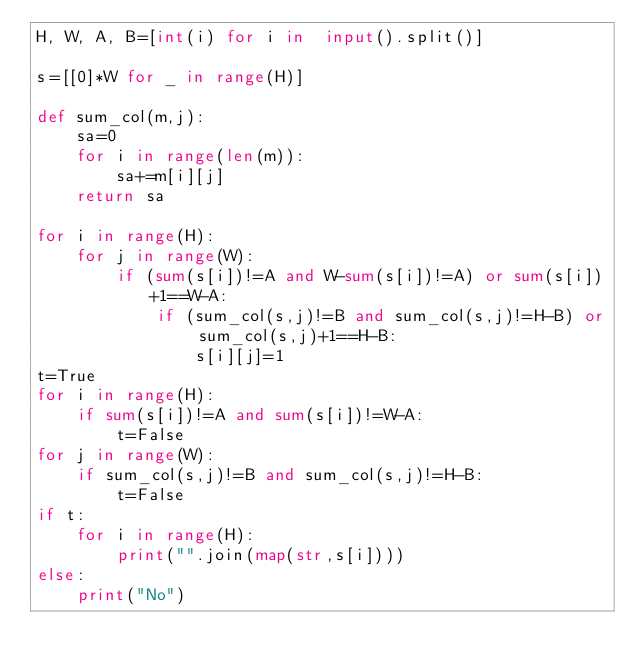Convert code to text. <code><loc_0><loc_0><loc_500><loc_500><_Python_>H, W, A, B=[int(i) for i in  input().split()]

s=[[0]*W for _ in range(H)]

def sum_col(m,j):
    sa=0
    for i in range(len(m)):
        sa+=m[i][j]
    return sa

for i in range(H):
    for j in range(W):
        if (sum(s[i])!=A and W-sum(s[i])!=A) or sum(s[i])+1==W-A:
            if (sum_col(s,j)!=B and sum_col(s,j)!=H-B) or sum_col(s,j)+1==H-B:
                s[i][j]=1
t=True
for i in range(H):
    if sum(s[i])!=A and sum(s[i])!=W-A:
        t=False
for j in range(W):
    if sum_col(s,j)!=B and sum_col(s,j)!=H-B:
        t=False
if t:
    for i in range(H):
        print("".join(map(str,s[i])))
else:
    print("No")</code> 